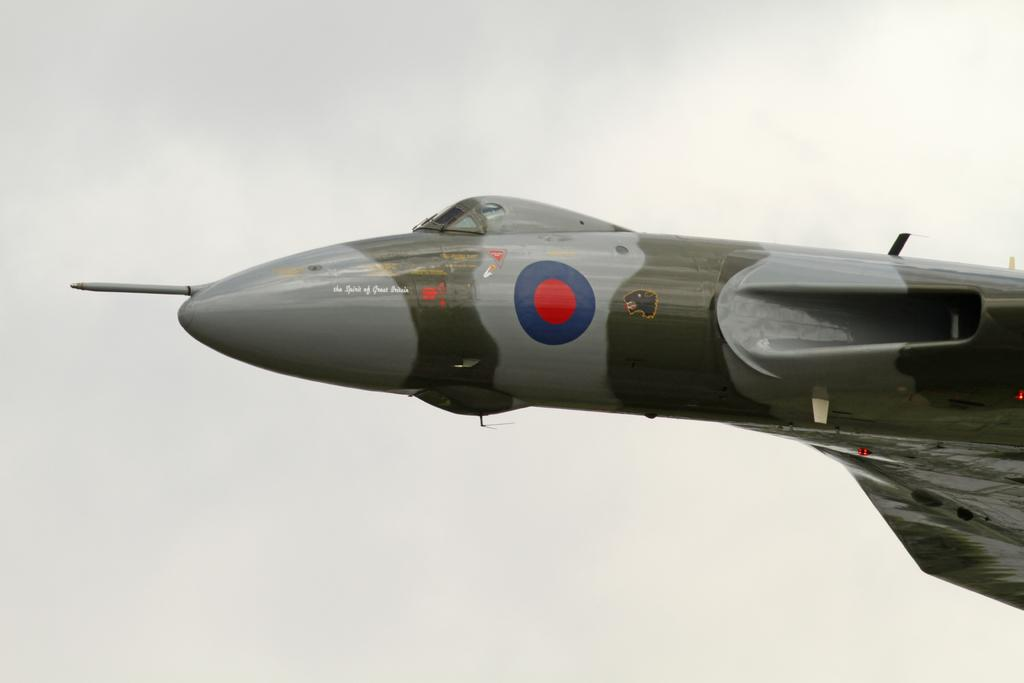What is the main subject of the picture? The main subject of the picture is an airplane. Can you describe any specific features of the airplane? Yes, there is writing on the airplane. What is the color of the background in the image? The background of the image is white. How many cows can be seen grazing in the background of the image? There are no cows present in the image; the background is white. What type of quartz is used to construct the airplane in the image? There is no mention of quartz or any construction material in the image; it simply shows an airplane with writing on it. 